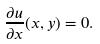<formula> <loc_0><loc_0><loc_500><loc_500>\frac { \partial u } { \partial x } ( x , y ) = 0 .</formula> 